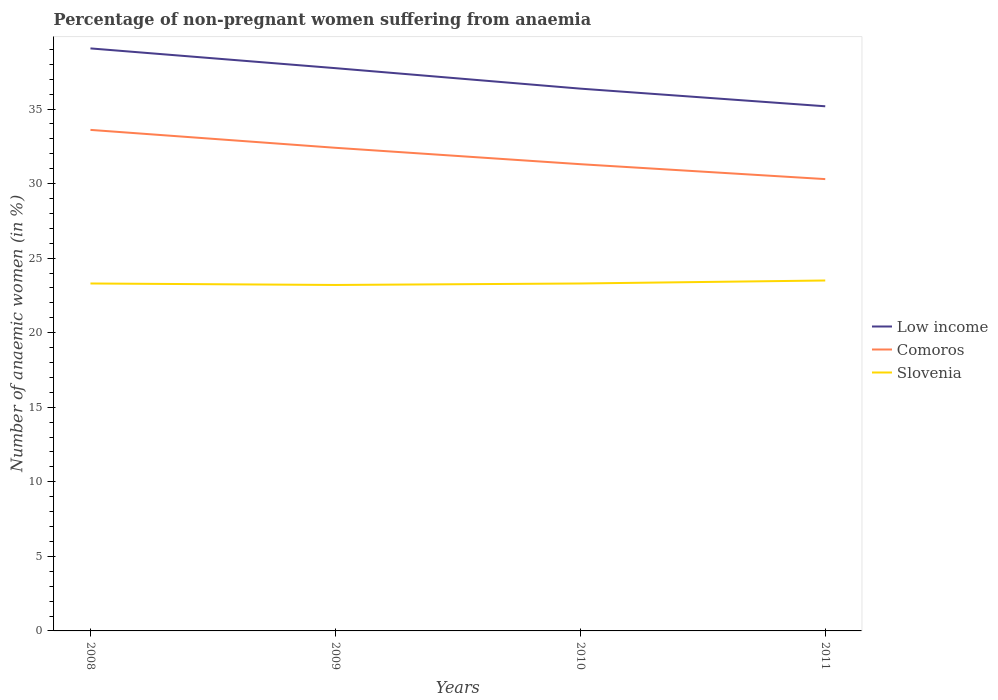Does the line corresponding to Comoros intersect with the line corresponding to Slovenia?
Your answer should be compact. No. Is the number of lines equal to the number of legend labels?
Offer a terse response. Yes. Across all years, what is the maximum percentage of non-pregnant women suffering from anaemia in Low income?
Provide a succinct answer. 35.18. What is the total percentage of non-pregnant women suffering from anaemia in Comoros in the graph?
Give a very brief answer. 1.1. What is the difference between the highest and the second highest percentage of non-pregnant women suffering from anaemia in Low income?
Offer a terse response. 3.88. How many lines are there?
Offer a very short reply. 3. How many years are there in the graph?
Give a very brief answer. 4. What is the title of the graph?
Provide a succinct answer. Percentage of non-pregnant women suffering from anaemia. What is the label or title of the X-axis?
Offer a very short reply. Years. What is the label or title of the Y-axis?
Give a very brief answer. Number of anaemic women (in %). What is the Number of anaemic women (in %) in Low income in 2008?
Make the answer very short. 39.06. What is the Number of anaemic women (in %) of Comoros in 2008?
Offer a very short reply. 33.6. What is the Number of anaemic women (in %) in Slovenia in 2008?
Make the answer very short. 23.3. What is the Number of anaemic women (in %) in Low income in 2009?
Ensure brevity in your answer.  37.74. What is the Number of anaemic women (in %) in Comoros in 2009?
Offer a very short reply. 32.4. What is the Number of anaemic women (in %) in Slovenia in 2009?
Provide a short and direct response. 23.2. What is the Number of anaemic women (in %) of Low income in 2010?
Offer a very short reply. 36.37. What is the Number of anaemic women (in %) of Comoros in 2010?
Give a very brief answer. 31.3. What is the Number of anaemic women (in %) in Slovenia in 2010?
Provide a succinct answer. 23.3. What is the Number of anaemic women (in %) in Low income in 2011?
Provide a succinct answer. 35.18. What is the Number of anaemic women (in %) of Comoros in 2011?
Your answer should be very brief. 30.3. Across all years, what is the maximum Number of anaemic women (in %) in Low income?
Your answer should be very brief. 39.06. Across all years, what is the maximum Number of anaemic women (in %) of Comoros?
Ensure brevity in your answer.  33.6. Across all years, what is the minimum Number of anaemic women (in %) in Low income?
Give a very brief answer. 35.18. Across all years, what is the minimum Number of anaemic women (in %) of Comoros?
Offer a terse response. 30.3. Across all years, what is the minimum Number of anaemic women (in %) of Slovenia?
Make the answer very short. 23.2. What is the total Number of anaemic women (in %) in Low income in the graph?
Your answer should be very brief. 148.36. What is the total Number of anaemic women (in %) in Comoros in the graph?
Give a very brief answer. 127.6. What is the total Number of anaemic women (in %) in Slovenia in the graph?
Your answer should be compact. 93.3. What is the difference between the Number of anaemic women (in %) in Low income in 2008 and that in 2009?
Give a very brief answer. 1.32. What is the difference between the Number of anaemic women (in %) of Comoros in 2008 and that in 2009?
Your answer should be very brief. 1.2. What is the difference between the Number of anaemic women (in %) in Low income in 2008 and that in 2010?
Your response must be concise. 2.7. What is the difference between the Number of anaemic women (in %) in Low income in 2008 and that in 2011?
Ensure brevity in your answer.  3.88. What is the difference between the Number of anaemic women (in %) of Comoros in 2008 and that in 2011?
Your answer should be very brief. 3.3. What is the difference between the Number of anaemic women (in %) in Low income in 2009 and that in 2010?
Keep it short and to the point. 1.37. What is the difference between the Number of anaemic women (in %) in Comoros in 2009 and that in 2010?
Offer a very short reply. 1.1. What is the difference between the Number of anaemic women (in %) of Low income in 2009 and that in 2011?
Provide a short and direct response. 2.56. What is the difference between the Number of anaemic women (in %) in Comoros in 2009 and that in 2011?
Offer a very short reply. 2.1. What is the difference between the Number of anaemic women (in %) in Slovenia in 2009 and that in 2011?
Offer a very short reply. -0.3. What is the difference between the Number of anaemic women (in %) of Low income in 2010 and that in 2011?
Offer a very short reply. 1.18. What is the difference between the Number of anaemic women (in %) of Comoros in 2010 and that in 2011?
Your answer should be compact. 1. What is the difference between the Number of anaemic women (in %) in Low income in 2008 and the Number of anaemic women (in %) in Comoros in 2009?
Your answer should be very brief. 6.66. What is the difference between the Number of anaemic women (in %) in Low income in 2008 and the Number of anaemic women (in %) in Slovenia in 2009?
Ensure brevity in your answer.  15.86. What is the difference between the Number of anaemic women (in %) in Low income in 2008 and the Number of anaemic women (in %) in Comoros in 2010?
Provide a short and direct response. 7.76. What is the difference between the Number of anaemic women (in %) of Low income in 2008 and the Number of anaemic women (in %) of Slovenia in 2010?
Your answer should be compact. 15.76. What is the difference between the Number of anaemic women (in %) of Comoros in 2008 and the Number of anaemic women (in %) of Slovenia in 2010?
Ensure brevity in your answer.  10.3. What is the difference between the Number of anaemic women (in %) in Low income in 2008 and the Number of anaemic women (in %) in Comoros in 2011?
Your answer should be compact. 8.76. What is the difference between the Number of anaemic women (in %) in Low income in 2008 and the Number of anaemic women (in %) in Slovenia in 2011?
Your answer should be very brief. 15.56. What is the difference between the Number of anaemic women (in %) in Low income in 2009 and the Number of anaemic women (in %) in Comoros in 2010?
Ensure brevity in your answer.  6.44. What is the difference between the Number of anaemic women (in %) in Low income in 2009 and the Number of anaemic women (in %) in Slovenia in 2010?
Your answer should be very brief. 14.44. What is the difference between the Number of anaemic women (in %) of Low income in 2009 and the Number of anaemic women (in %) of Comoros in 2011?
Offer a terse response. 7.44. What is the difference between the Number of anaemic women (in %) of Low income in 2009 and the Number of anaemic women (in %) of Slovenia in 2011?
Keep it short and to the point. 14.24. What is the difference between the Number of anaemic women (in %) in Low income in 2010 and the Number of anaemic women (in %) in Comoros in 2011?
Ensure brevity in your answer.  6.07. What is the difference between the Number of anaemic women (in %) of Low income in 2010 and the Number of anaemic women (in %) of Slovenia in 2011?
Make the answer very short. 12.87. What is the difference between the Number of anaemic women (in %) in Comoros in 2010 and the Number of anaemic women (in %) in Slovenia in 2011?
Your answer should be compact. 7.8. What is the average Number of anaemic women (in %) in Low income per year?
Give a very brief answer. 37.09. What is the average Number of anaemic women (in %) in Comoros per year?
Offer a very short reply. 31.9. What is the average Number of anaemic women (in %) in Slovenia per year?
Ensure brevity in your answer.  23.32. In the year 2008, what is the difference between the Number of anaemic women (in %) in Low income and Number of anaemic women (in %) in Comoros?
Offer a terse response. 5.46. In the year 2008, what is the difference between the Number of anaemic women (in %) in Low income and Number of anaemic women (in %) in Slovenia?
Give a very brief answer. 15.76. In the year 2009, what is the difference between the Number of anaemic women (in %) of Low income and Number of anaemic women (in %) of Comoros?
Your answer should be very brief. 5.34. In the year 2009, what is the difference between the Number of anaemic women (in %) in Low income and Number of anaemic women (in %) in Slovenia?
Provide a succinct answer. 14.54. In the year 2009, what is the difference between the Number of anaemic women (in %) of Comoros and Number of anaemic women (in %) of Slovenia?
Ensure brevity in your answer.  9.2. In the year 2010, what is the difference between the Number of anaemic women (in %) in Low income and Number of anaemic women (in %) in Comoros?
Give a very brief answer. 5.07. In the year 2010, what is the difference between the Number of anaemic women (in %) in Low income and Number of anaemic women (in %) in Slovenia?
Provide a short and direct response. 13.07. In the year 2011, what is the difference between the Number of anaemic women (in %) of Low income and Number of anaemic women (in %) of Comoros?
Your answer should be very brief. 4.88. In the year 2011, what is the difference between the Number of anaemic women (in %) of Low income and Number of anaemic women (in %) of Slovenia?
Keep it short and to the point. 11.68. What is the ratio of the Number of anaemic women (in %) of Low income in 2008 to that in 2009?
Your answer should be very brief. 1.04. What is the ratio of the Number of anaemic women (in %) of Low income in 2008 to that in 2010?
Keep it short and to the point. 1.07. What is the ratio of the Number of anaemic women (in %) of Comoros in 2008 to that in 2010?
Provide a short and direct response. 1.07. What is the ratio of the Number of anaemic women (in %) in Low income in 2008 to that in 2011?
Offer a terse response. 1.11. What is the ratio of the Number of anaemic women (in %) in Comoros in 2008 to that in 2011?
Ensure brevity in your answer.  1.11. What is the ratio of the Number of anaemic women (in %) in Low income in 2009 to that in 2010?
Your answer should be compact. 1.04. What is the ratio of the Number of anaemic women (in %) in Comoros in 2009 to that in 2010?
Make the answer very short. 1.04. What is the ratio of the Number of anaemic women (in %) of Low income in 2009 to that in 2011?
Offer a terse response. 1.07. What is the ratio of the Number of anaemic women (in %) of Comoros in 2009 to that in 2011?
Your answer should be compact. 1.07. What is the ratio of the Number of anaemic women (in %) in Slovenia in 2009 to that in 2011?
Your response must be concise. 0.99. What is the ratio of the Number of anaemic women (in %) in Low income in 2010 to that in 2011?
Offer a very short reply. 1.03. What is the ratio of the Number of anaemic women (in %) of Comoros in 2010 to that in 2011?
Your answer should be compact. 1.03. What is the difference between the highest and the second highest Number of anaemic women (in %) in Low income?
Ensure brevity in your answer.  1.32. What is the difference between the highest and the lowest Number of anaemic women (in %) of Low income?
Give a very brief answer. 3.88. What is the difference between the highest and the lowest Number of anaemic women (in %) of Slovenia?
Offer a very short reply. 0.3. 